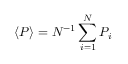<formula> <loc_0><loc_0><loc_500><loc_500>\langle P \rangle = N ^ { - 1 } \sum _ { i = 1 } ^ { N } P _ { i }</formula> 